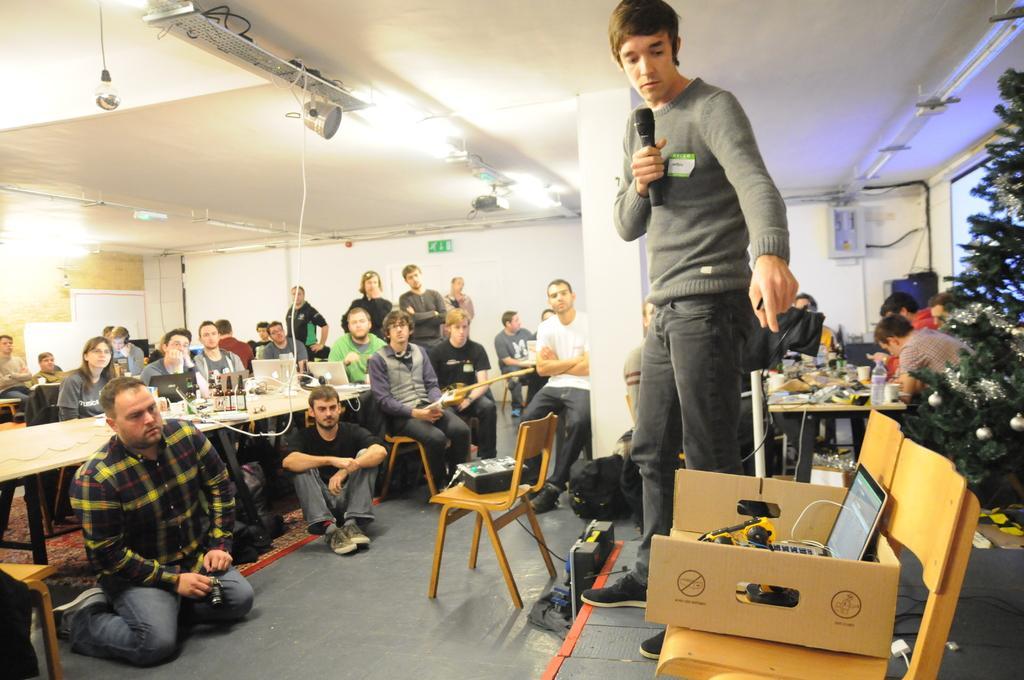Describe this image in one or two sentences. There are many persons sitting and standing. One person is standing on the stage and holding a mic. There are chairs and tables in this room. On the chair there is a box. On the box there is a laptop. There is a Christmas tree on the right side. There are some people sitting. There is a table. On the table there are many items. In the ceiling there are lights. On the wall there is a sign board. On the table there are bottles, laptops and many other items. And there is carpet on the floor. 